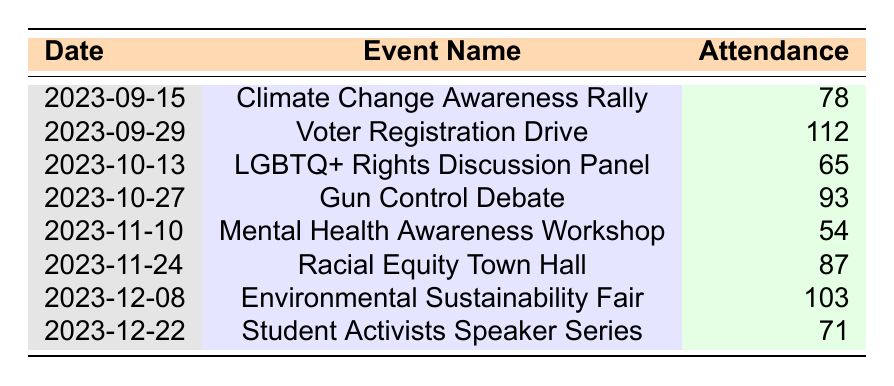What event had the highest attendance? By looking at the attendance numbers, the Voter Registration Drive on 2023-09-29 had the highest attendance at 112.
Answer: Voter Registration Drive What is the attendance of the Mental Health Awareness Workshop? The table shows that the attendance for the Mental Health Awareness Workshop on 2023-11-10 was 54.
Answer: 54 What are the total attendance numbers for all events? To find the total, we sum the attendance: 78 + 112 + 65 + 93 + 54 + 87 + 103 + 71 = 763.
Answer: 763 What is the average attendance across all events? We sum the attendance numbers to get 763, then divide by the number of events (8), giving us an average attendance of 763/8 = 95.375.
Answer: 95.375 Was there an event with attendance below 60? Yes, the LGBTQ+ Rights Discussion Panel had an attendance of 65, while the Mental Health Awareness Workshop had an attendance of 54, which is below 60.
Answer: Yes What event occurred on 2023-12-08? The event that occurred on this date is the Environmental Sustainability Fair, which had an attendance of 103.
Answer: Environmental Sustainability Fair Which two events had attendance numbers that add up to more than 150? We check pairs: Voter Registration Drive (112) and any other: 112 + 78 = 190, qualifies. Voter Registration Drive (112) + Gun Control Debate (93) = 205, qualifies. Racial Equity Town Hall (87) + Environmental Sustainability Fair (103) = 190, qualifies. So, there are several qualifying pairs.
Answer: Voter Registration Drive + Gun Control Debate What percentage of the total attendance does the Climate Change Awareness Rally represent? The Climate Change Awareness Rally had an attendance of 78. To find its percentage of total attendance (763), we do (78/763) * 100 = approximately 10.23%.
Answer: 10.23% Which event had the lowest attendance, and what was that number? The event with the lowest attendance is the Mental Health Awareness Workshop, which had an attendance of 54.
Answer: Mental Health Awareness Workshop, 54 How many events had attendance numbers greater than 80? We see that 5 events had attendance greater than 80: Voter Registration Drive (112), Gun Control Debate (93), Racial Equity Town Hall (87), Environmental Sustainability Fair (103).
Answer: 4 events 